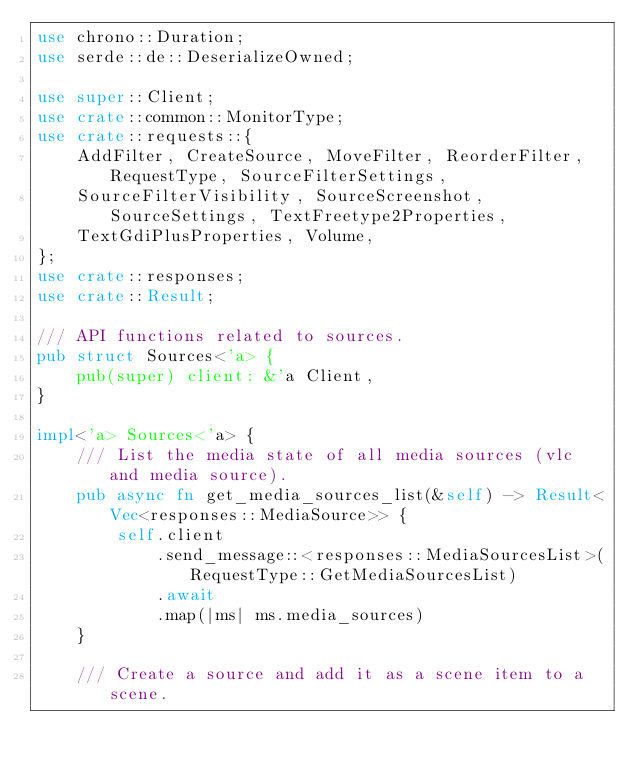<code> <loc_0><loc_0><loc_500><loc_500><_Rust_>use chrono::Duration;
use serde::de::DeserializeOwned;

use super::Client;
use crate::common::MonitorType;
use crate::requests::{
    AddFilter, CreateSource, MoveFilter, ReorderFilter, RequestType, SourceFilterSettings,
    SourceFilterVisibility, SourceScreenshot, SourceSettings, TextFreetype2Properties,
    TextGdiPlusProperties, Volume,
};
use crate::responses;
use crate::Result;

/// API functions related to sources.
pub struct Sources<'a> {
    pub(super) client: &'a Client,
}

impl<'a> Sources<'a> {
    /// List the media state of all media sources (vlc and media source).
    pub async fn get_media_sources_list(&self) -> Result<Vec<responses::MediaSource>> {
        self.client
            .send_message::<responses::MediaSourcesList>(RequestType::GetMediaSourcesList)
            .await
            .map(|ms| ms.media_sources)
    }

    /// Create a source and add it as a scene item to a scene.</code> 